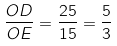Convert formula to latex. <formula><loc_0><loc_0><loc_500><loc_500>\frac { O D } { O E } = \frac { 2 5 } { 1 5 } = \frac { 5 } { 3 }</formula> 